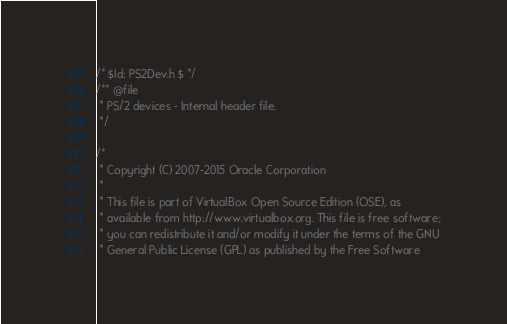<code> <loc_0><loc_0><loc_500><loc_500><_C_>/* $Id: PS2Dev.h $ */
/** @file
 * PS/2 devices - Internal header file.
 */

/*
 * Copyright (C) 2007-2015 Oracle Corporation
 *
 * This file is part of VirtualBox Open Source Edition (OSE), as
 * available from http://www.virtualbox.org. This file is free software;
 * you can redistribute it and/or modify it under the terms of the GNU
 * General Public License (GPL) as published by the Free Software</code> 